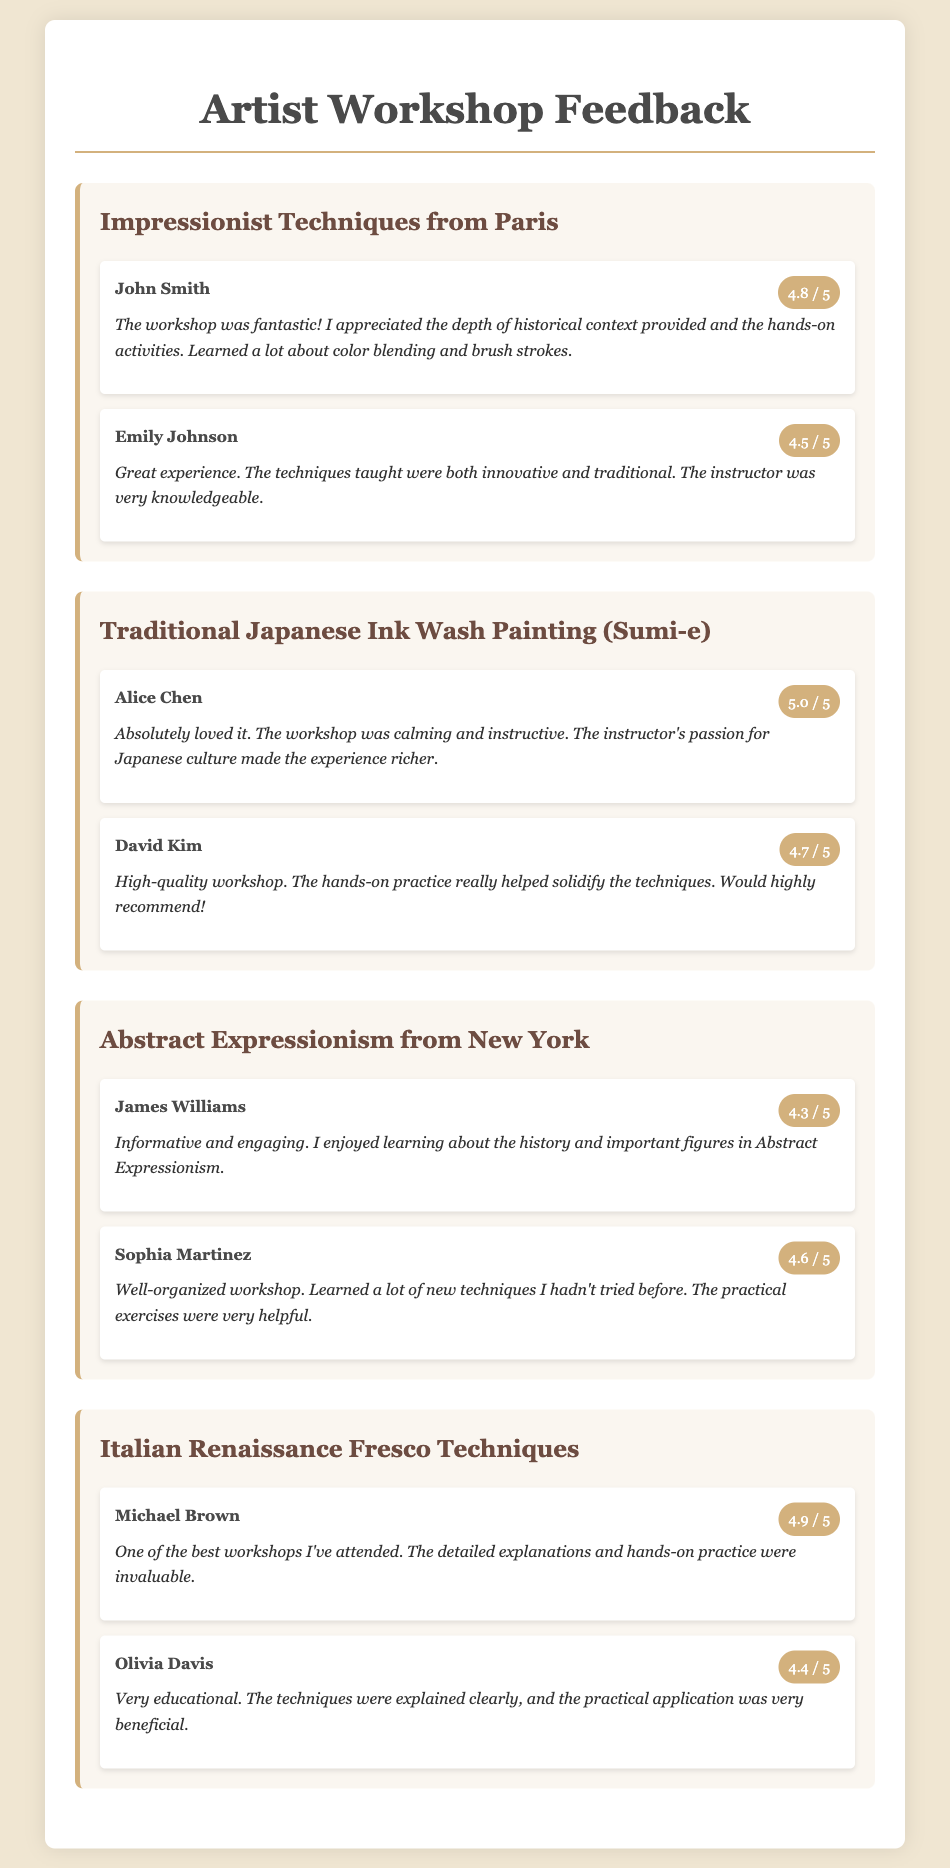what is the average rating of the workshop "Impressionist Techniques from Paris"? The average rating is calculated by adding the ratings given (4.8 + 4.5) and dividing by the number of evaluations (2), resulting in an average of 4.65.
Answer: 4.65 who gave a rating of 5.0 for the workshop "Traditional Japanese Ink Wash Painting (Sumi-e)"? The feedback document lists Alice Chen as the participant who rated this workshop 5.0.
Answer: Alice Chen how many evaluations are provided for the workshop "Abstract Expressionism from New York"? The document shows two evaluations listed under the "Abstract Expressionism from New York" workshop, indicating the number of evaluations.
Answer: 2 what is the main theme of the workshop titled "Italian Renaissance Fresco Techniques"? The title itself suggests that the main theme involves traditional fresco techniques, which are characteristic of the Italian Renaissance art style.
Answer: Fresco techniques which participant provided a comment stating the workshop was "calming and instructive"? The feedback document cites Alice Chen as having expressed that sentiment in her comments about the Sumi-e workshop.
Answer: Alice Chen what is the lowest rating received in the document? The lowest rating can be determined by examining all provided ratings, revealing that the one given for the "Abstract Expressionism from New York" workshop is 4.3.
Answer: 4.3 how many workshops are mentioned in the feedback document? The document lists a total of four distinct workshops within the content provided.
Answer: 4 which workshop received the highest rating from any participant? By reviewing the provided ratings, it can be concluded that the workshop "Traditional Japanese Ink Wash Painting (Sumi-e)" received the highest individual rating of 5.0.
Answer: Traditional Japanese Ink Wash Painting (Sumi-e) 